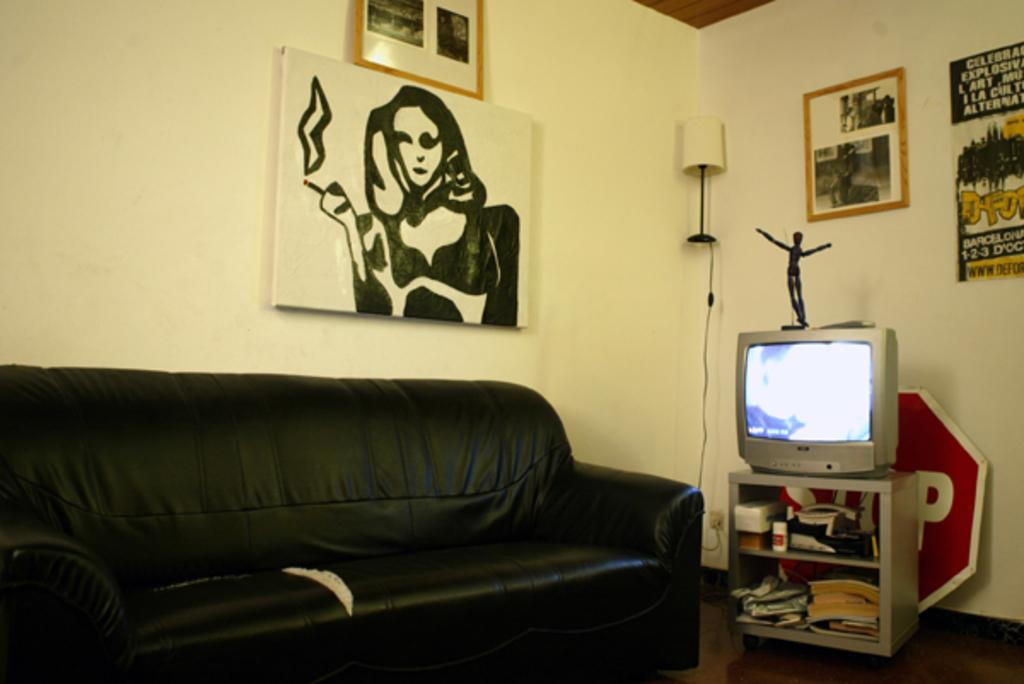What type of furniture is present in the image? There is a couch in the image. What type of electronic device is visible in the image? There is a television in the image. What can be seen on the wall in the image? There are frames on the wall. What type of lighting is present in the image? There is a lamp on the wall. What type of items can be seen on the rack in the image? There are objects on the rack in the image. What type of reading material is present in the image? There are books in the image. What type of cloth is being used to cover the queen in the image? There is no queen or cloth present in the image. How does the lamp on the wall burn in the image? The lamp on the wall does not burn in the image; it is an electric lamp. 